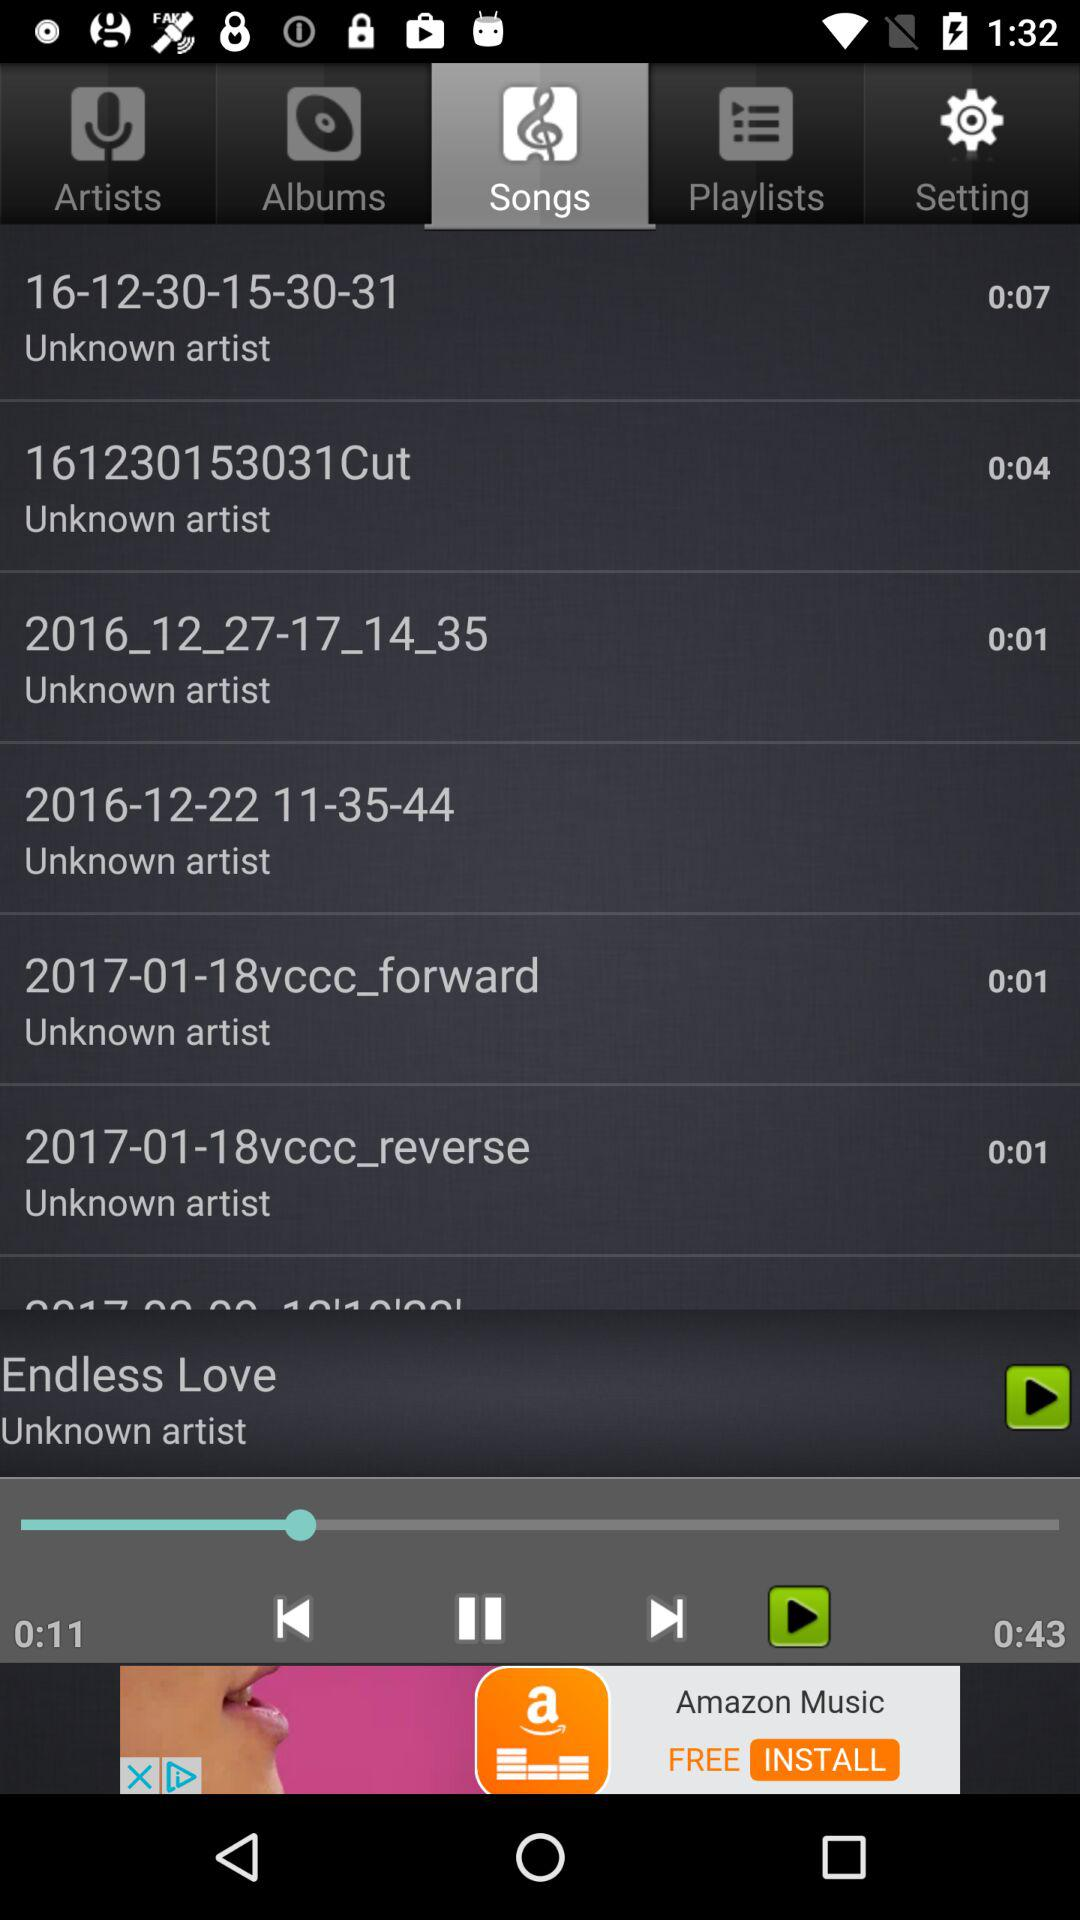How long has the song been played? The song has been played for 11 seconds. 